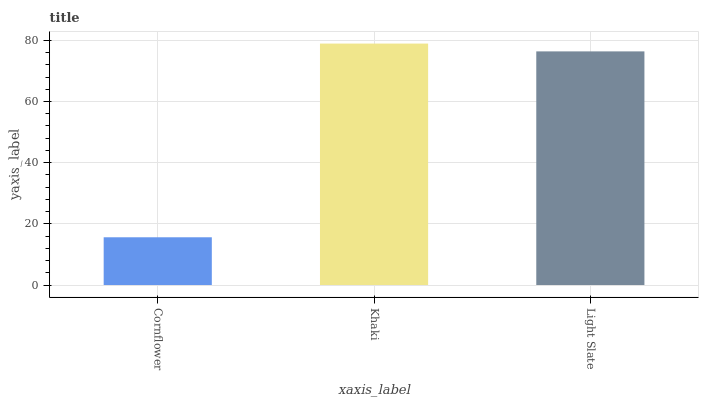Is Cornflower the minimum?
Answer yes or no. Yes. Is Khaki the maximum?
Answer yes or no. Yes. Is Light Slate the minimum?
Answer yes or no. No. Is Light Slate the maximum?
Answer yes or no. No. Is Khaki greater than Light Slate?
Answer yes or no. Yes. Is Light Slate less than Khaki?
Answer yes or no. Yes. Is Light Slate greater than Khaki?
Answer yes or no. No. Is Khaki less than Light Slate?
Answer yes or no. No. Is Light Slate the high median?
Answer yes or no. Yes. Is Light Slate the low median?
Answer yes or no. Yes. Is Cornflower the high median?
Answer yes or no. No. Is Khaki the low median?
Answer yes or no. No. 